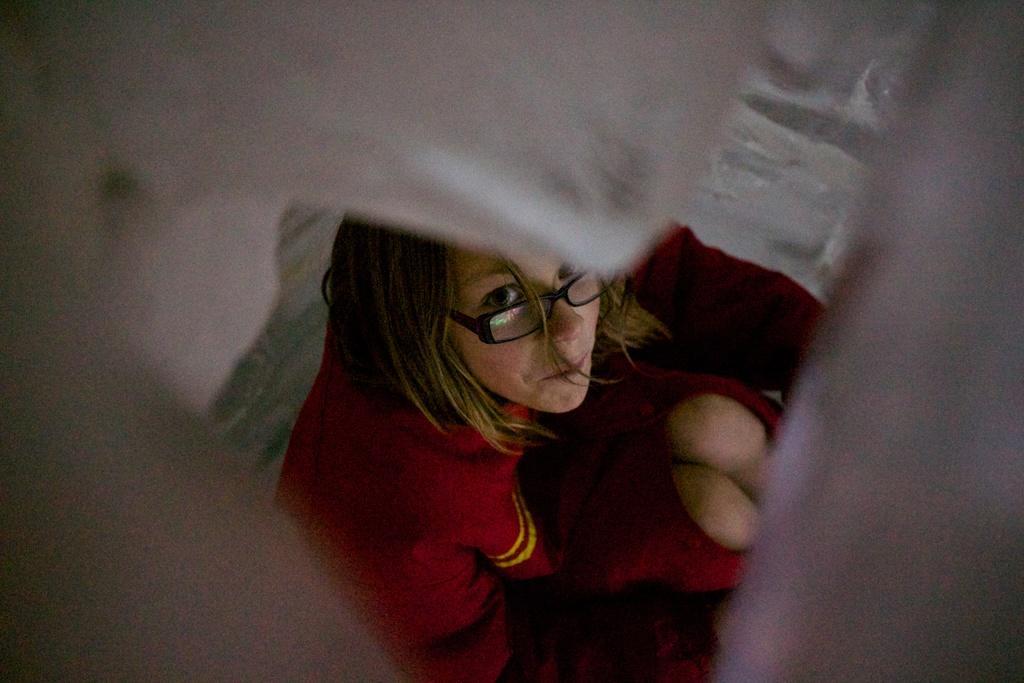Could you give a brief overview of what you see in this image? In the center of the picture there is a woman in red dress. On the edges there is an object. 